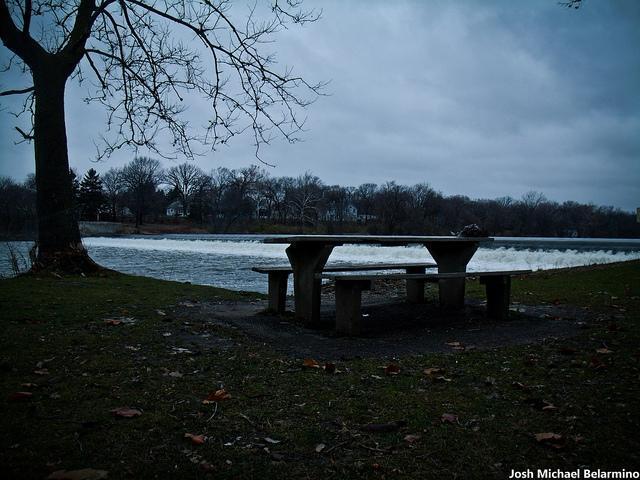How many trees show roots?
Give a very brief answer. 1. How many train cars are painted black?
Give a very brief answer. 0. 